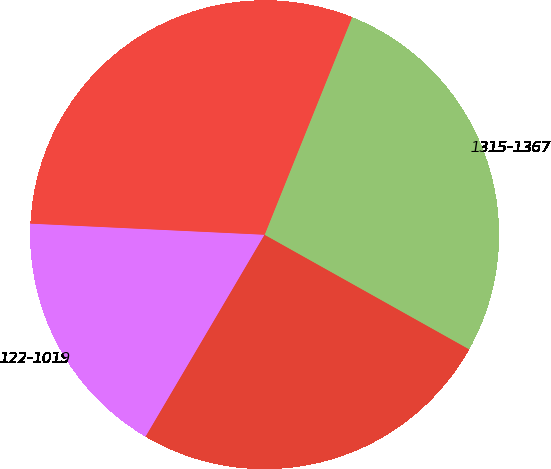Convert chart. <chart><loc_0><loc_0><loc_500><loc_500><pie_chart><fcel>122-1019<fcel>1028-1311<fcel>1315-1367<fcel>1369-1556<nl><fcel>17.28%<fcel>25.35%<fcel>27.04%<fcel>30.33%<nl></chart> 